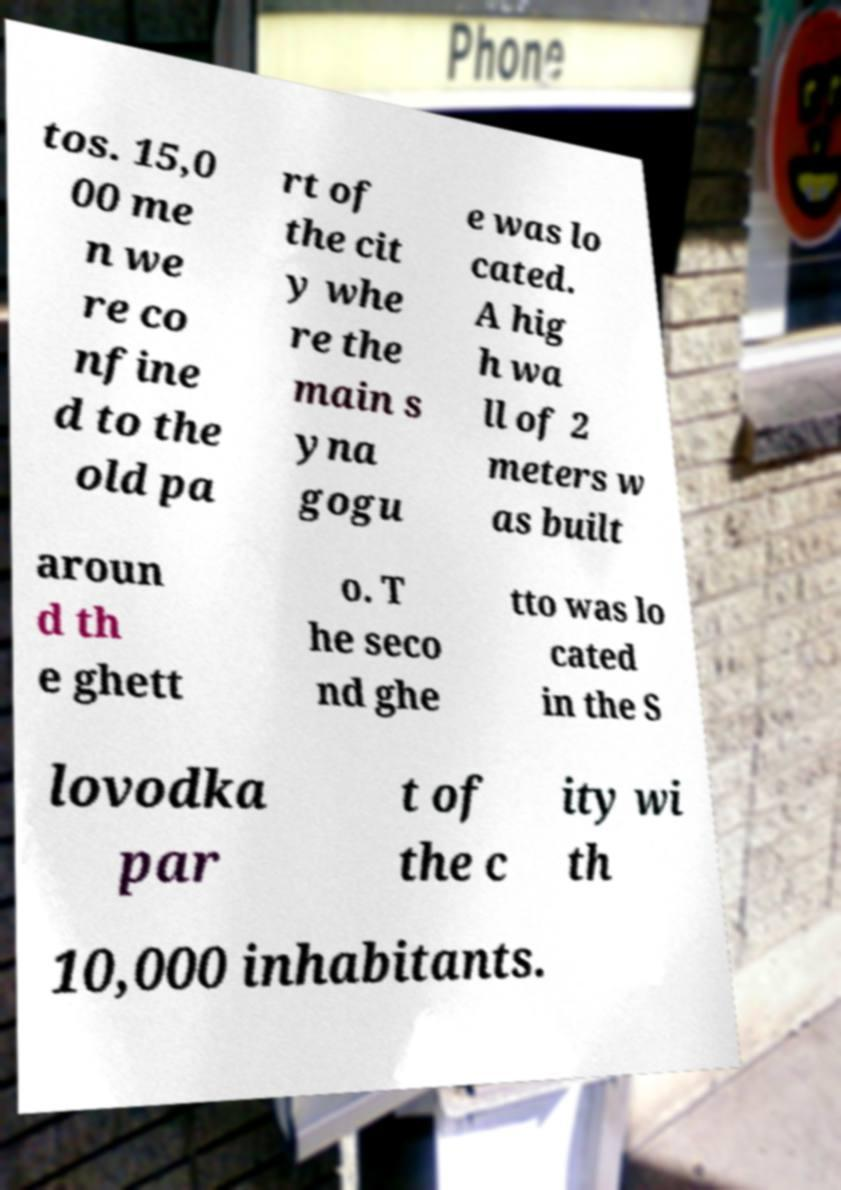Please identify and transcribe the text found in this image. tos. 15,0 00 me n we re co nfine d to the old pa rt of the cit y whe re the main s yna gogu e was lo cated. A hig h wa ll of 2 meters w as built aroun d th e ghett o. T he seco nd ghe tto was lo cated in the S lovodka par t of the c ity wi th 10,000 inhabitants. 